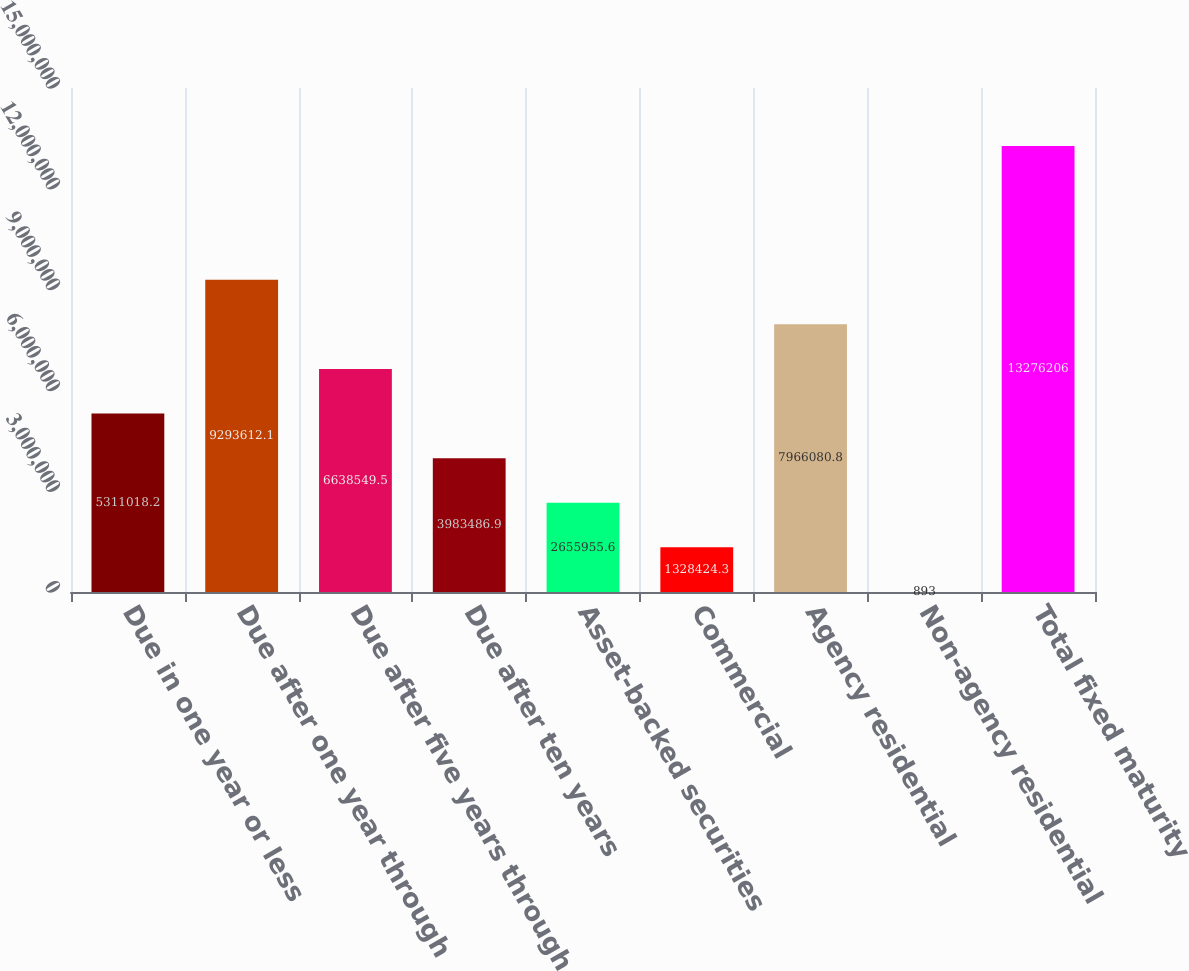Convert chart to OTSL. <chart><loc_0><loc_0><loc_500><loc_500><bar_chart><fcel>Due in one year or less<fcel>Due after one year through<fcel>Due after five years through<fcel>Due after ten years<fcel>Asset-backed securities<fcel>Commercial<fcel>Agency residential<fcel>Non-agency residential<fcel>Total fixed maturity<nl><fcel>5.31102e+06<fcel>9.29361e+06<fcel>6.63855e+06<fcel>3.98349e+06<fcel>2.65596e+06<fcel>1.32842e+06<fcel>7.96608e+06<fcel>893<fcel>1.32762e+07<nl></chart> 